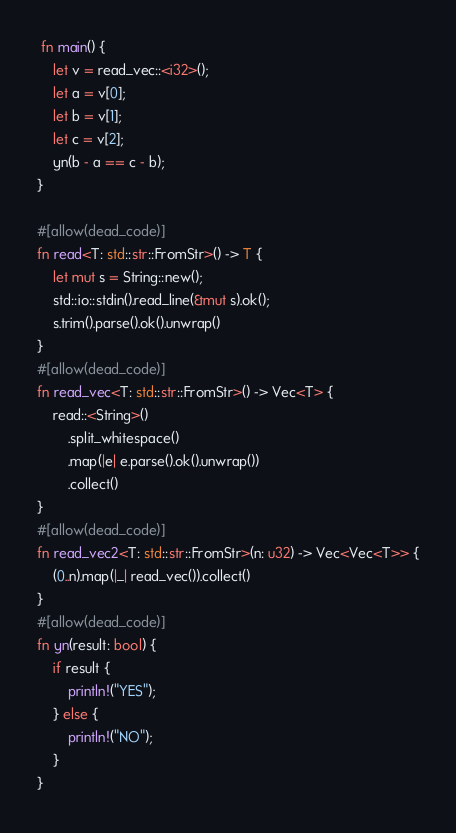Convert code to text. <code><loc_0><loc_0><loc_500><loc_500><_Rust_> fn main() {
    let v = read_vec::<i32>();
    let a = v[0];
    let b = v[1];
    let c = v[2];
    yn(b - a == c - b);
}

#[allow(dead_code)]
fn read<T: std::str::FromStr>() -> T {
    let mut s = String::new();
    std::io::stdin().read_line(&mut s).ok();
    s.trim().parse().ok().unwrap()
}
#[allow(dead_code)]
fn read_vec<T: std::str::FromStr>() -> Vec<T> {
    read::<String>()
        .split_whitespace()
        .map(|e| e.parse().ok().unwrap())
        .collect()
}
#[allow(dead_code)]
fn read_vec2<T: std::str::FromStr>(n: u32) -> Vec<Vec<T>> {
    (0..n).map(|_| read_vec()).collect()
}
#[allow(dead_code)]
fn yn(result: bool) {
    if result {
        println!("YES");
    } else {
        println!("NO");
    }
}
</code> 